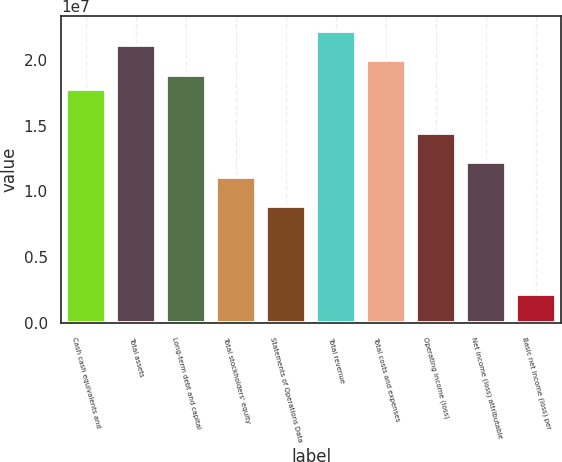Convert chart to OTSL. <chart><loc_0><loc_0><loc_500><loc_500><bar_chart><fcel>Cash cash equivalents and<fcel>Total assets<fcel>Long-term debt and capital<fcel>Total stockholders' equity<fcel>Statements of Operations Data<fcel>Total revenue<fcel>Total costs and expenses<fcel>Operating income (loss)<fcel>Net income (loss) attributable<fcel>Basic net income (loss) per<nl><fcel>1.77446e+07<fcel>2.10717e+07<fcel>1.88536e+07<fcel>1.10904e+07<fcel>8.8723e+06<fcel>2.21807e+07<fcel>1.99627e+07<fcel>1.44175e+07<fcel>1.21994e+07<fcel>2.21808e+06<nl></chart> 